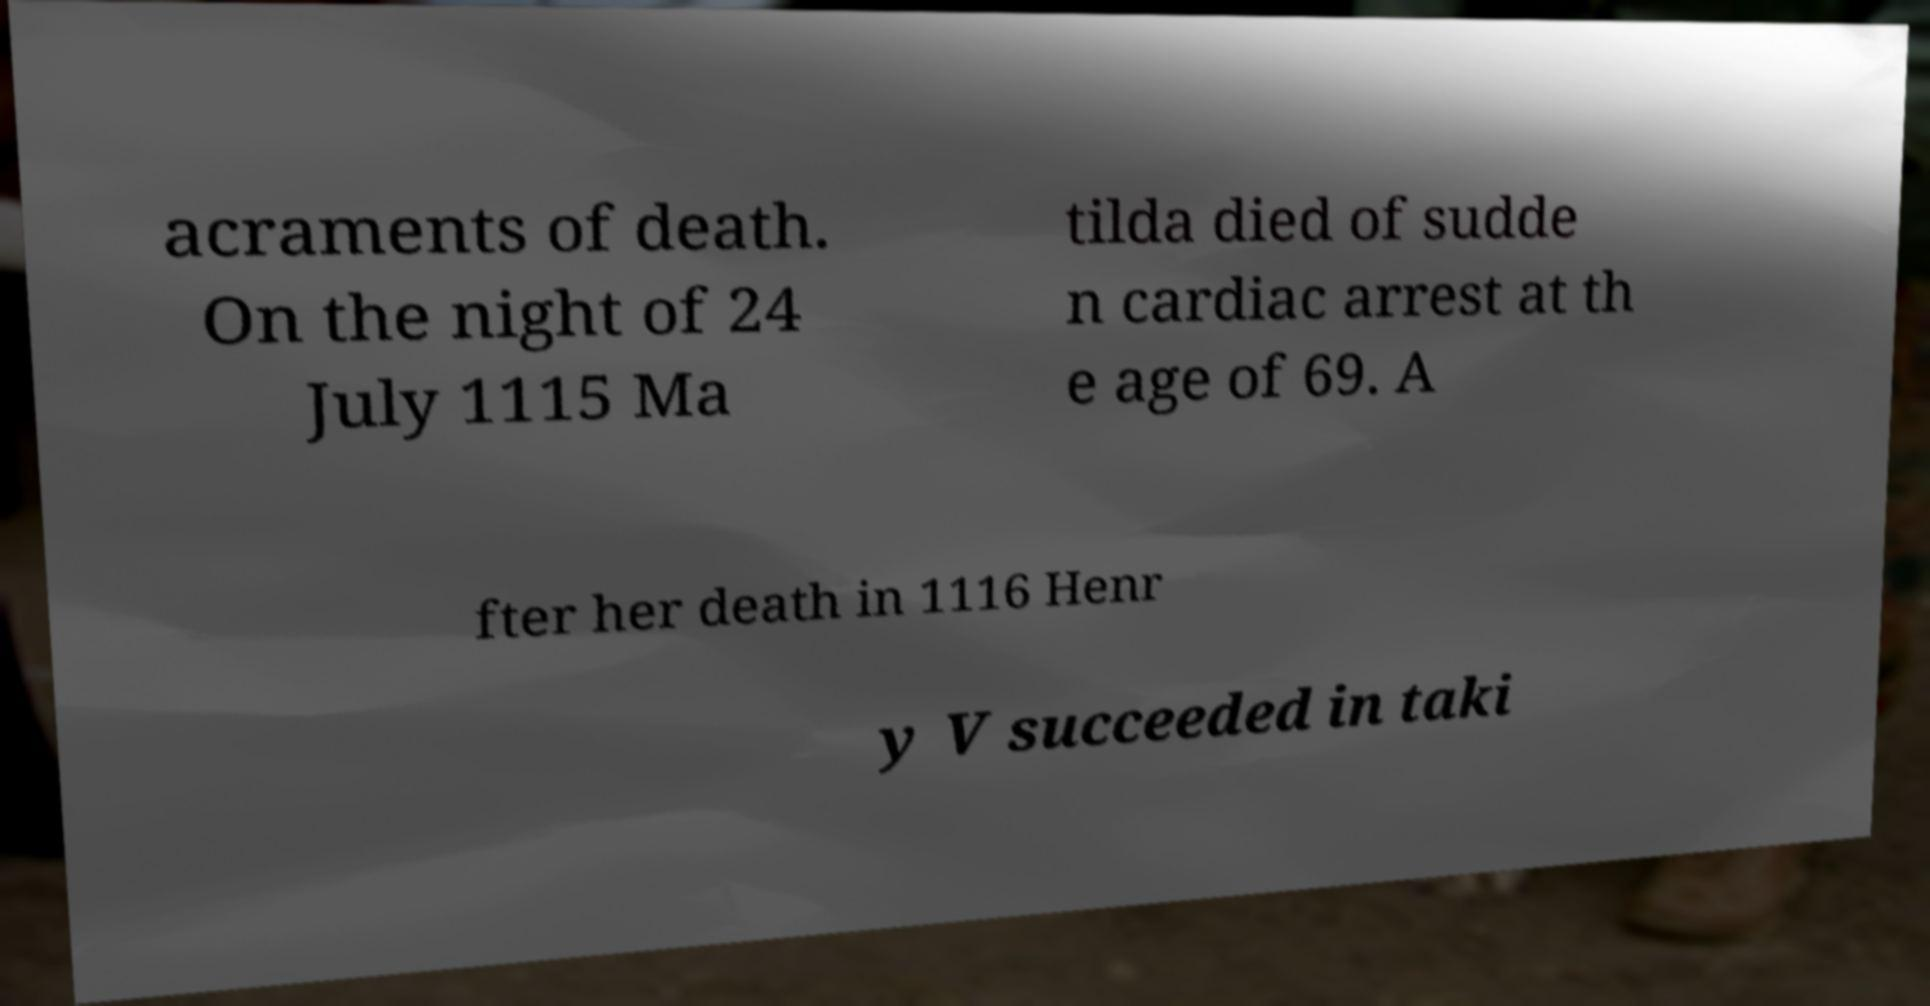Could you assist in decoding the text presented in this image and type it out clearly? acraments of death. On the night of 24 July 1115 Ma tilda died of sudde n cardiac arrest at th e age of 69. A fter her death in 1116 Henr y V succeeded in taki 